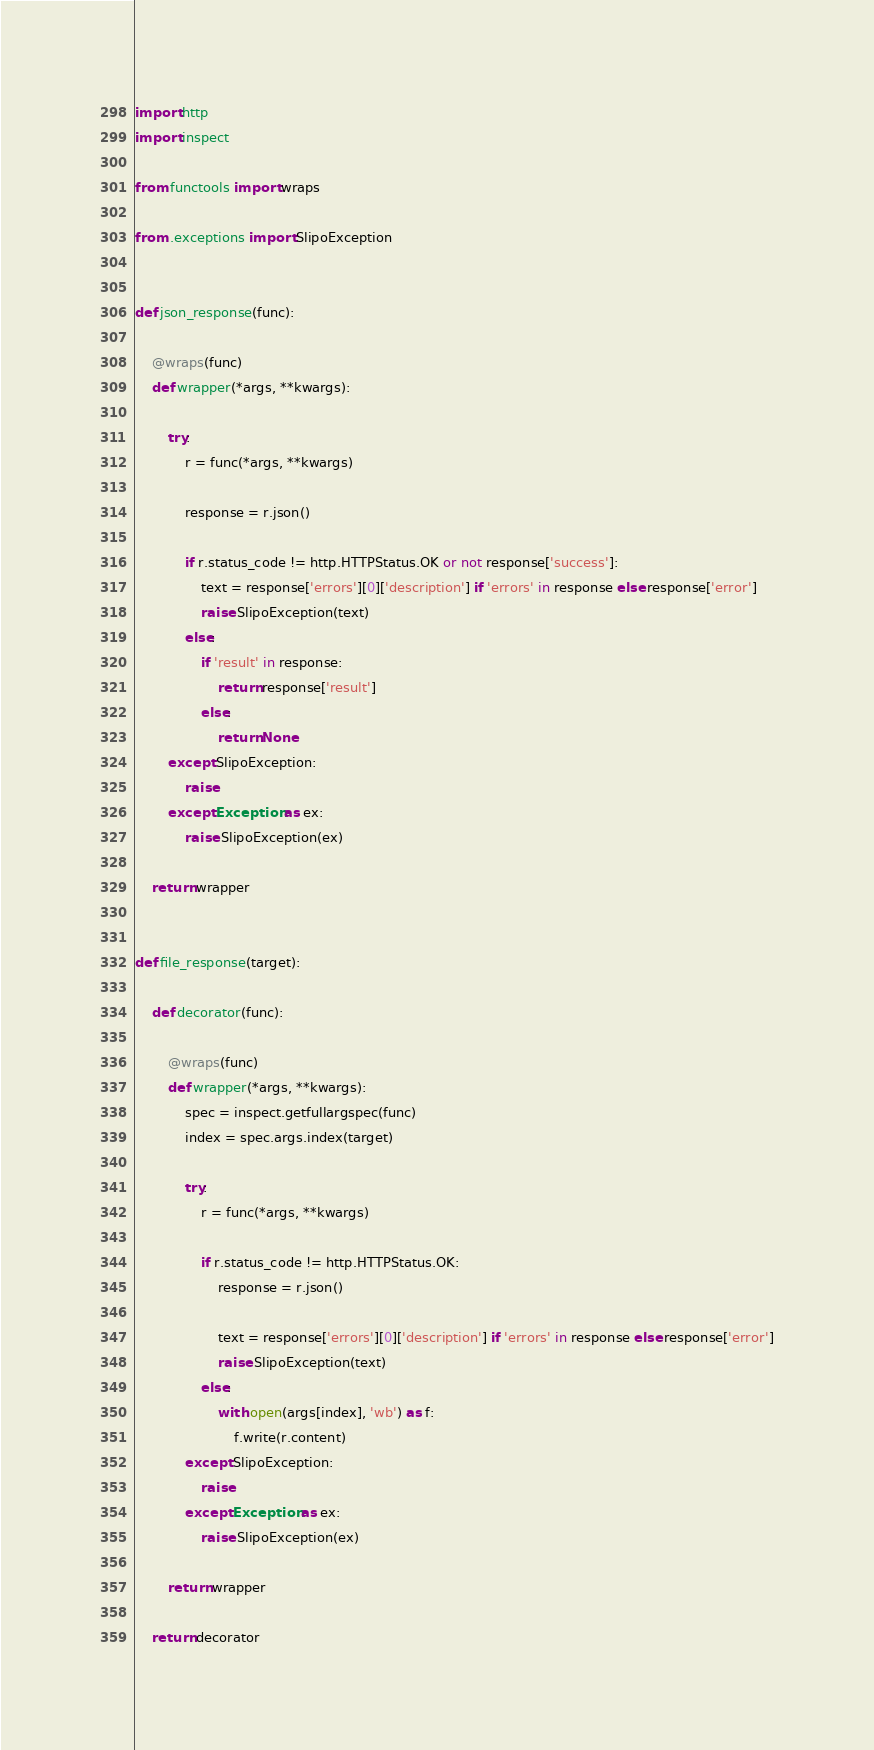<code> <loc_0><loc_0><loc_500><loc_500><_Python_>import http
import inspect

from functools import wraps

from .exceptions import SlipoException


def json_response(func):

    @wraps(func)
    def wrapper(*args, **kwargs):

        try:
            r = func(*args, **kwargs)

            response = r.json()

            if r.status_code != http.HTTPStatus.OK or not response['success']:
                text = response['errors'][0]['description'] if 'errors' in response else response['error']
                raise SlipoException(text)
            else:
                if 'result' in response:
                    return response['result']
                else:
                    return None
        except SlipoException:
            raise
        except Exception as ex:
            raise SlipoException(ex)

    return wrapper


def file_response(target):

    def decorator(func):

        @wraps(func)
        def wrapper(*args, **kwargs):
            spec = inspect.getfullargspec(func)
            index = spec.args.index(target)

            try:
                r = func(*args, **kwargs)

                if r.status_code != http.HTTPStatus.OK:
                    response = r.json()

                    text = response['errors'][0]['description'] if 'errors' in response else response['error']
                    raise SlipoException(text)
                else:
                    with open(args[index], 'wb') as f:
                        f.write(r.content)
            except SlipoException:
                raise
            except Exception as ex:
                raise SlipoException(ex)

        return wrapper

    return decorator
</code> 